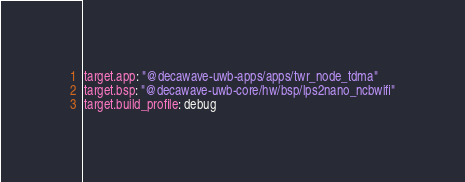Convert code to text. <code><loc_0><loc_0><loc_500><loc_500><_YAML_>target.app: "@decawave-uwb-apps/apps/twr_node_tdma"
target.bsp: "@decawave-uwb-core/hw/bsp/lps2nano_ncbwifi"
target.build_profile: debug
</code> 